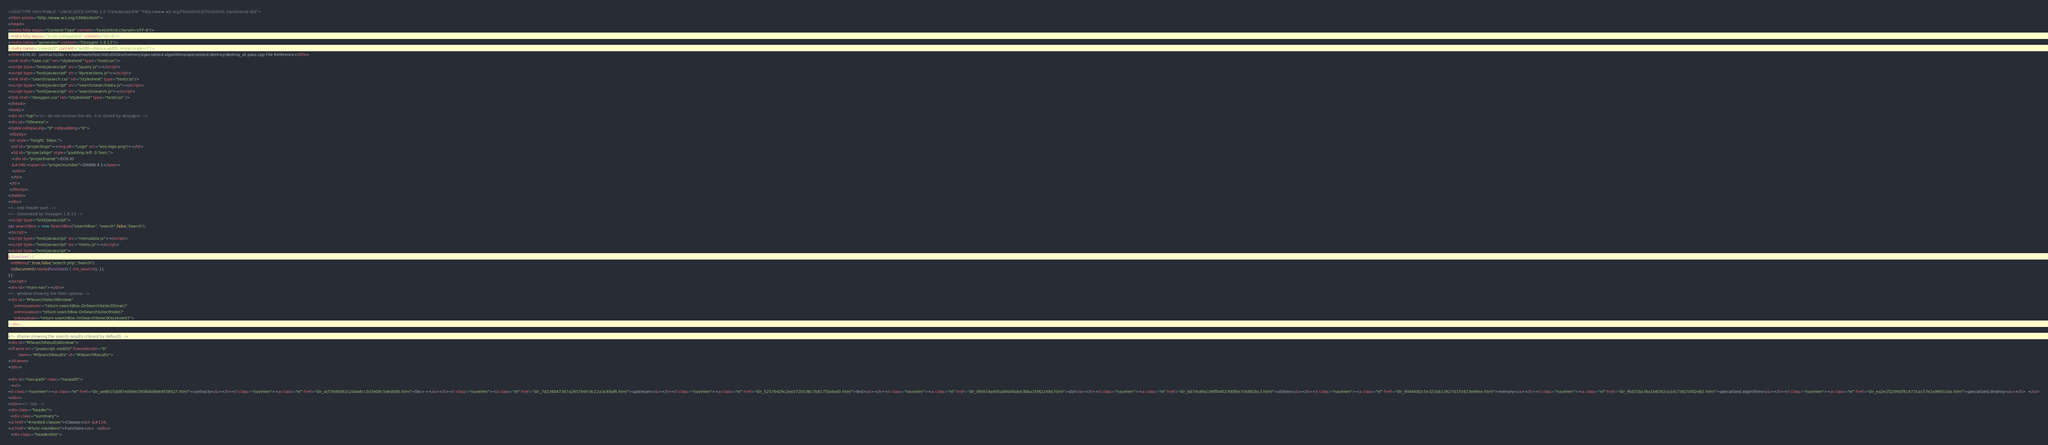<code> <loc_0><loc_0><loc_500><loc_500><_HTML_><!DOCTYPE html PUBLIC "-//W3C//DTD XHTML 1.0 Transitional//EN" "http://www.w3.org/TR/xhtml1/DTD/xhtml1-transitional.dtd">
<html xmlns="http://www.w3.org/1999/xhtml">
<head>
<meta http-equiv="Content-Type" content="text/xhtml;charset=UTF-8"/>
<meta http-equiv="X-UA-Compatible" content="IE=9"/>
<meta name="generator" content="Doxygen 1.8.13"/>
<meta name="viewport" content="width=device-width, initial-scale=1"/>
<title>EOS.IO: contracts/libc++/upstream/test/std/utilities/memory/specialized.algorithms/specialized.destroy/destroy_at.pass.cpp File Reference</title>
<link href="tabs.css" rel="stylesheet" type="text/css"/>
<script type="text/javascript" src="jquery.js"></script>
<script type="text/javascript" src="dynsections.js"></script>
<link href="search/search.css" rel="stylesheet" type="text/css"/>
<script type="text/javascript" src="search/searchdata.js"></script>
<script type="text/javascript" src="search/search.js"></script>
<link href="doxygen.css" rel="stylesheet" type="text/css" />
</head>
<body>
<div id="top"><!-- do not remove this div, it is closed by doxygen! -->
<div id="titlearea">
<table cellspacing="0" cellpadding="0">
 <tbody>
 <tr style="height: 56px;">
  <td id="projectlogo"><img alt="Logo" src="eos-logo.png"/></td>
  <td id="projectalign" style="padding-left: 0.5em;">
   <div id="projectname">EOS.IO
   &#160;<span id="projectnumber">DAWN 4.1</span>
   </div>
  </td>
 </tr>
 </tbody>
</table>
</div>
<!-- end header part -->
<!-- Generated by Doxygen 1.8.13 -->
<script type="text/javascript">
var searchBox = new SearchBox("searchBox", "search",false,'Search');
</script>
<script type="text/javascript" src="menudata.js"></script>
<script type="text/javascript" src="menu.js"></script>
<script type="text/javascript">
$(function() {
  initMenu('',true,false,'search.php','Search');
  $(document).ready(function() { init_search(); });
});
</script>
<div id="main-nav"></div>
<!-- window showing the filter options -->
<div id="MSearchSelectWindow"
     onmouseover="return searchBox.OnSearchSelectShow()"
     onmouseout="return searchBox.OnSearchSelectHide()"
     onkeydown="return searchBox.OnSearchSelectKey(event)">
</div>

<!-- iframe showing the search results (closed by default) -->
<div id="MSearchResultsWindow">
<iframe src="javascript:void(0)" frameborder="0" 
        name="MSearchResults" id="MSearchResults">
</iframe>
</div>

<div id="nav-path" class="navpath">
  <ul>
<li class="navelem"><a class="el" href="dir_ae9b15dd87e066e1908bbd90e8f38627.html">contracts</a></li><li class="navelem"><a class="el" href="dir_acf7646062c2dda4cc5d3e08c5ded00b.html">libc++</a></li><li class="navelem"><a class="el" href="dir_7d236047367a2957b6fc9c22a3c49af8.html">upstream</a></li><li class="navelem"><a class="el" href="dir_52576429c2ea572b538c7b817f3a6ed0.html">test</a></li><li class="navelem"><a class="el" href="dir_8fe919a9d5a89b0babe3bba35f42248d.html">std</a></li><li class="navelem"><a class="el" href="dir_bb74c89a194ffb402300fbe7c6882bc3.html">utilities</a></li><li class="navelem"><a class="el" href="dir_9946682c5e323ab13627d370423e96ee.html">memory</a></li><li class="navelem"><a class="el" href="dir_f6d31ba36a1b6582ca1dc73825082e82.html">specialized.algorithms</a></li><li class="navelem"><a class="el" href="dir_ea2e2f22960f814731ac57e2a99932da.html">specialized.destroy</a></li>  </ul>
</div>
</div><!-- top -->
<div class="header">
  <div class="summary">
<a href="#nested-classes">Classes</a> &#124;
<a href="#func-members">Functions</a>  </div>
  <div class="headertitle"></code> 